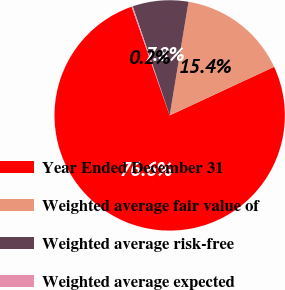<chart> <loc_0><loc_0><loc_500><loc_500><pie_chart><fcel>Year Ended December 31<fcel>Weighted average fair value of<fcel>Weighted average risk-free<fcel>Weighted average expected<nl><fcel>76.58%<fcel>15.45%<fcel>7.81%<fcel>0.17%<nl></chart> 